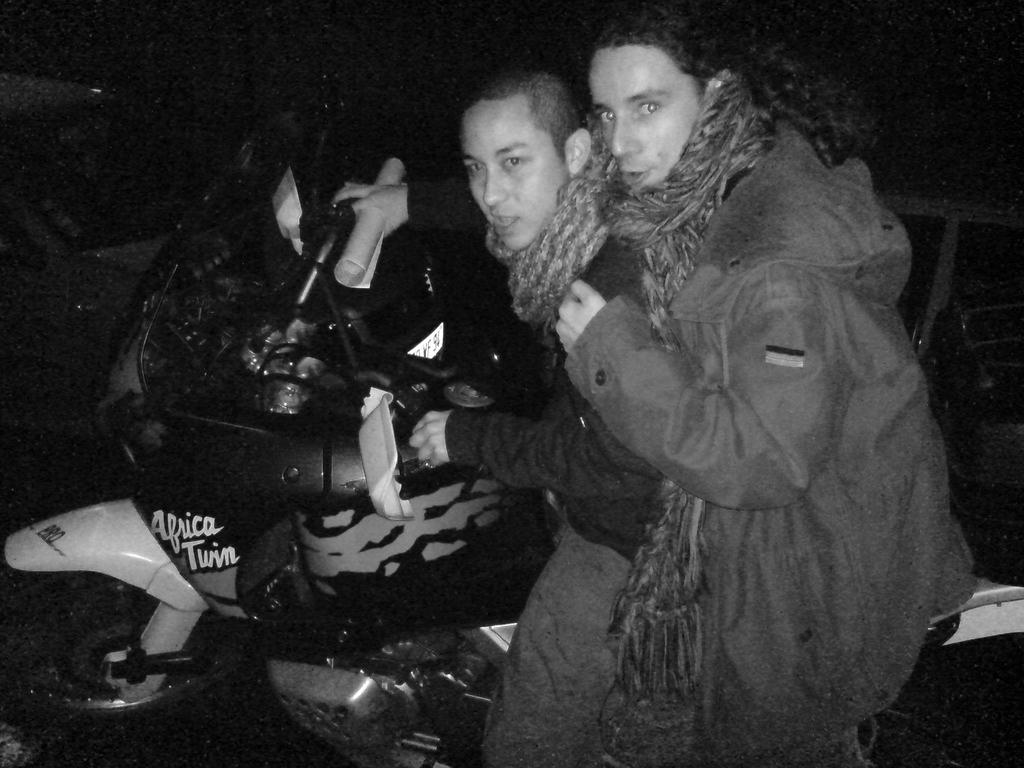What is the color scheme of the image? The image is in black and white. How many people are in the image? There are two men in the image. What are the men doing in the image? The men are sitting on a bike. What type of soup is being served in the image? There is no soup present in the image; it features two men sitting on a bike. Can you tell me how many goats are visible in the image? There are no goats present in the image. 